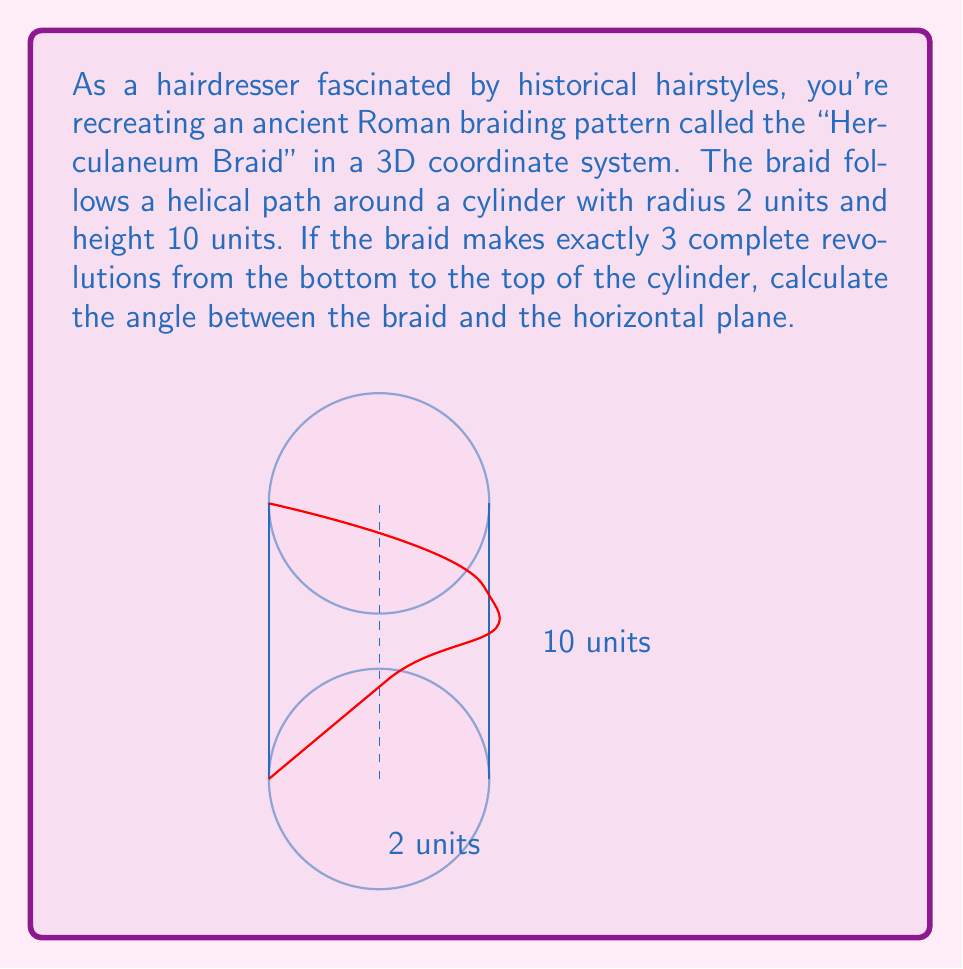Can you answer this question? Let's approach this step-by-step:

1) In a 3D coordinate system, we can represent the helical path of the braid using parametric equations:

   $$x = r \cos(t)$$
   $$y = r \sin(t)$$
   $$z = ht/(2\pi n)$$

   Where $r$ is the radius, $h$ is the height, $n$ is the number of revolutions, and $t$ is the parameter (0 ≤ t ≤ 2πn).

2) In this case, $r = 2$, $h = 10$, and $n = 3$.

3) To find the angle between the braid and the horizontal plane, we need to calculate the pitch angle of the helix. This is the angle between the tangent to the helix and the horizontal plane.

4) The tangent vector to the helix at any point is given by:

   $$\vec{T} = \left(-r\sin(t), r\cos(t), \frac{h}{2\pi n}\right)$$

5) The angle θ between this vector and the horizontal plane is:

   $$\tan(\theta) = \frac{\text{vertical component}}{\text{magnitude of horizontal component}}$$

6) The vertical component is constant: $h/(2\pi n)$

7) The magnitude of the horizontal component is $\sqrt{(r\sin(t))^2 + (r\cos(t))^2} = r$

8) Therefore:

   $$\tan(\theta) = \frac{h}{2\pi nr} = \frac{10}{2\pi \cdot 3 \cdot 2} = \frac{5}{6\pi}$$

9) Taking the inverse tangent:

   $$\theta = \arctan\left(\frac{5}{6\pi}\right)$$
Answer: $\arctan\left(\frac{5}{6\pi}\right)$ radians or approximately 14.9° 